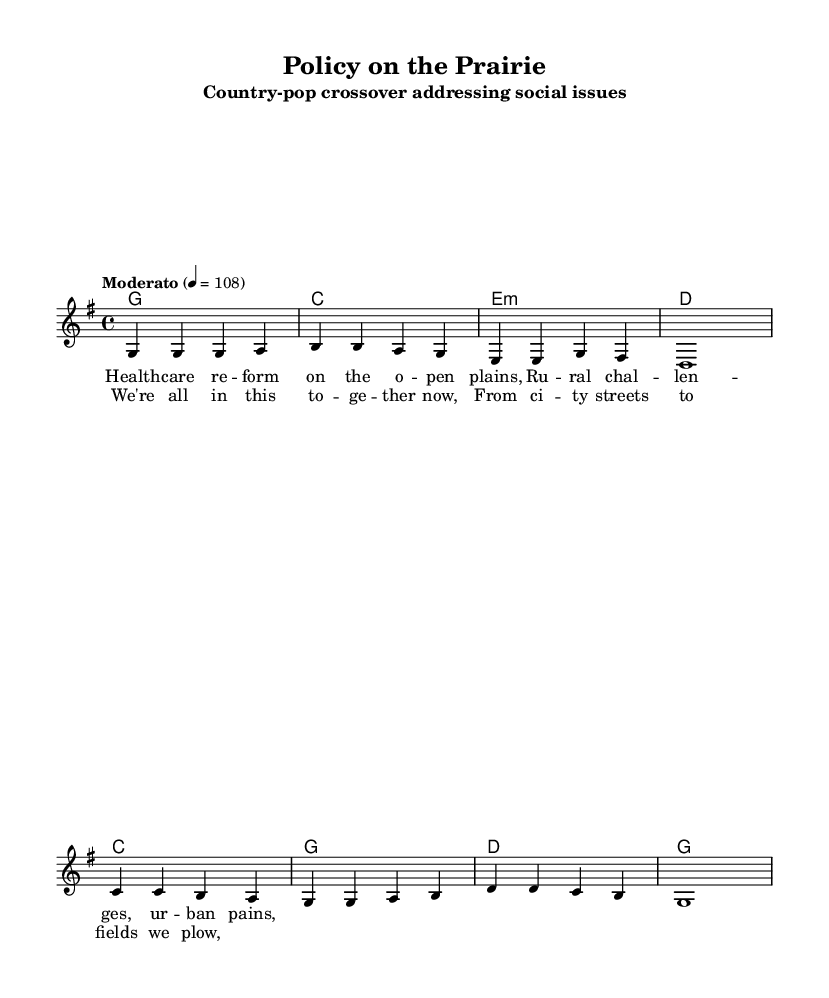What is the key signature of this music? The key signature is G major, which has one sharp (F#). This can be determined by identifying the number of sharps or flats indicated at the beginning of the staff.
Answer: G major What is the time signature of this piece? The time signature is 4/4, which is visible in the notation at the beginning of the score. This means there are four beats in each measure and a quarter note receives one beat.
Answer: 4/4 What is the tempo of the music? The tempo is marked as "Moderato" with a metronome marking of 108 beats per minute, which indicates a moderate pace. This information is presented at the beginning of the score, under the tempo indication.
Answer: Moderato, 108 How many measures are in the verse? The verse consists of four measures, as can be counted from the notation of the melody section where the melody notes are arranged. Each group of notes separated by a vertical bar represents one measure.
Answer: 4 What lyrical themes are present in the verse? The verse discusses themes of healthcare reform and rural challenges, which can be derived from the lyrics provided in the sheet music. The focus on social issues is evident through the specific phrases used in the lyrics.
Answer: Healthcare reform, rural challenges What is the primary chord progression used in the chorus? The primary chord progression in the chorus is C - G - D - G, which can be analyzed by looking at the chords listed above the melody notes in the chorus section. This shows the harmonic structure supporting the vocal line.
Answer: C - G - D - G 